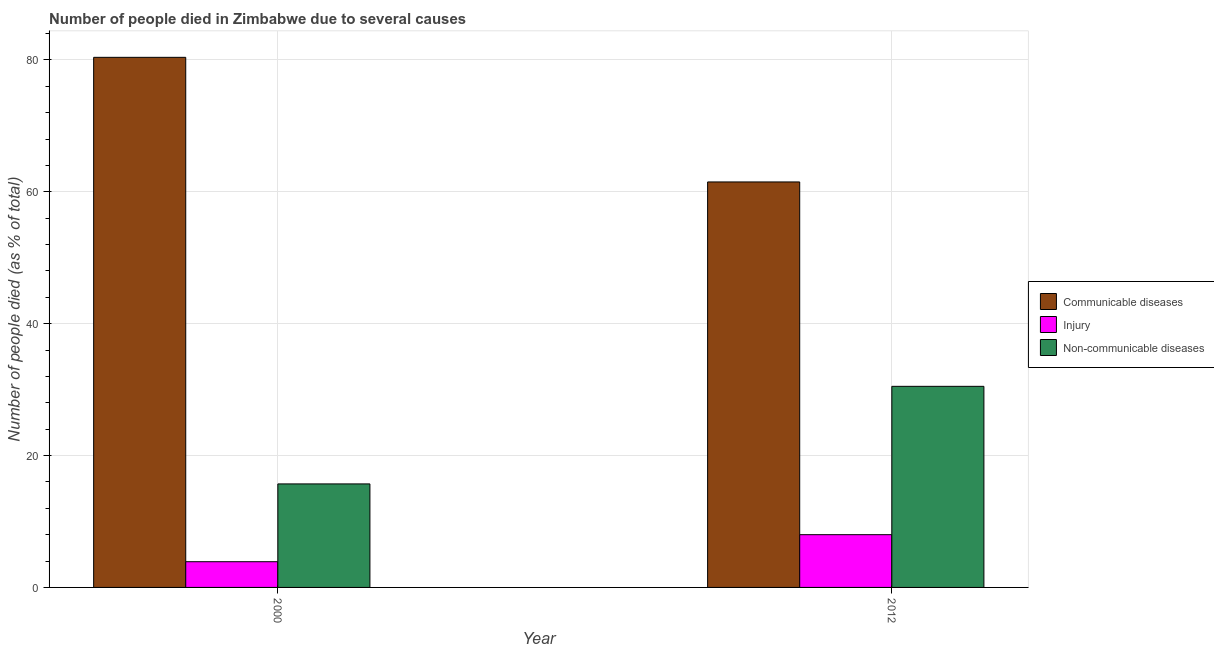Are the number of bars per tick equal to the number of legend labels?
Provide a succinct answer. Yes. Are the number of bars on each tick of the X-axis equal?
Provide a succinct answer. Yes. How many bars are there on the 2nd tick from the left?
Offer a terse response. 3. What is the label of the 1st group of bars from the left?
Provide a short and direct response. 2000. What is the number of people who dies of non-communicable diseases in 2012?
Your answer should be very brief. 30.5. Across all years, what is the maximum number of people who died of communicable diseases?
Give a very brief answer. 80.4. What is the total number of people who died of communicable diseases in the graph?
Your answer should be compact. 141.9. What is the difference between the number of people who died of communicable diseases in 2000 and that in 2012?
Keep it short and to the point. 18.9. What is the difference between the number of people who died of communicable diseases in 2000 and the number of people who died of injury in 2012?
Offer a terse response. 18.9. What is the average number of people who dies of non-communicable diseases per year?
Provide a short and direct response. 23.1. In the year 2012, what is the difference between the number of people who dies of non-communicable diseases and number of people who died of communicable diseases?
Ensure brevity in your answer.  0. In how many years, is the number of people who died of communicable diseases greater than 72 %?
Offer a very short reply. 1. What is the ratio of the number of people who died of communicable diseases in 2000 to that in 2012?
Your response must be concise. 1.31. Is the number of people who dies of non-communicable diseases in 2000 less than that in 2012?
Give a very brief answer. Yes. In how many years, is the number of people who died of communicable diseases greater than the average number of people who died of communicable diseases taken over all years?
Keep it short and to the point. 1. What does the 1st bar from the left in 2000 represents?
Your response must be concise. Communicable diseases. What does the 2nd bar from the right in 2000 represents?
Make the answer very short. Injury. Is it the case that in every year, the sum of the number of people who died of communicable diseases and number of people who died of injury is greater than the number of people who dies of non-communicable diseases?
Give a very brief answer. Yes. Are all the bars in the graph horizontal?
Give a very brief answer. No. How many years are there in the graph?
Your answer should be compact. 2. What is the difference between two consecutive major ticks on the Y-axis?
Make the answer very short. 20. Does the graph contain any zero values?
Give a very brief answer. No. Does the graph contain grids?
Offer a very short reply. Yes. What is the title of the graph?
Offer a terse response. Number of people died in Zimbabwe due to several causes. What is the label or title of the Y-axis?
Your response must be concise. Number of people died (as % of total). What is the Number of people died (as % of total) of Communicable diseases in 2000?
Give a very brief answer. 80.4. What is the Number of people died (as % of total) of Communicable diseases in 2012?
Give a very brief answer. 61.5. What is the Number of people died (as % of total) in Injury in 2012?
Ensure brevity in your answer.  8. What is the Number of people died (as % of total) in Non-communicable diseases in 2012?
Your response must be concise. 30.5. Across all years, what is the maximum Number of people died (as % of total) in Communicable diseases?
Offer a terse response. 80.4. Across all years, what is the maximum Number of people died (as % of total) of Non-communicable diseases?
Keep it short and to the point. 30.5. Across all years, what is the minimum Number of people died (as % of total) in Communicable diseases?
Provide a short and direct response. 61.5. Across all years, what is the minimum Number of people died (as % of total) in Non-communicable diseases?
Make the answer very short. 15.7. What is the total Number of people died (as % of total) of Communicable diseases in the graph?
Ensure brevity in your answer.  141.9. What is the total Number of people died (as % of total) of Non-communicable diseases in the graph?
Your answer should be very brief. 46.2. What is the difference between the Number of people died (as % of total) in Communicable diseases in 2000 and that in 2012?
Offer a very short reply. 18.9. What is the difference between the Number of people died (as % of total) in Injury in 2000 and that in 2012?
Give a very brief answer. -4.1. What is the difference between the Number of people died (as % of total) of Non-communicable diseases in 2000 and that in 2012?
Your answer should be very brief. -14.8. What is the difference between the Number of people died (as % of total) in Communicable diseases in 2000 and the Number of people died (as % of total) in Injury in 2012?
Your answer should be very brief. 72.4. What is the difference between the Number of people died (as % of total) of Communicable diseases in 2000 and the Number of people died (as % of total) of Non-communicable diseases in 2012?
Give a very brief answer. 49.9. What is the difference between the Number of people died (as % of total) in Injury in 2000 and the Number of people died (as % of total) in Non-communicable diseases in 2012?
Give a very brief answer. -26.6. What is the average Number of people died (as % of total) in Communicable diseases per year?
Your answer should be very brief. 70.95. What is the average Number of people died (as % of total) in Injury per year?
Your answer should be compact. 5.95. What is the average Number of people died (as % of total) of Non-communicable diseases per year?
Give a very brief answer. 23.1. In the year 2000, what is the difference between the Number of people died (as % of total) in Communicable diseases and Number of people died (as % of total) in Injury?
Keep it short and to the point. 76.5. In the year 2000, what is the difference between the Number of people died (as % of total) in Communicable diseases and Number of people died (as % of total) in Non-communicable diseases?
Your answer should be very brief. 64.7. In the year 2000, what is the difference between the Number of people died (as % of total) of Injury and Number of people died (as % of total) of Non-communicable diseases?
Provide a succinct answer. -11.8. In the year 2012, what is the difference between the Number of people died (as % of total) of Communicable diseases and Number of people died (as % of total) of Injury?
Your response must be concise. 53.5. In the year 2012, what is the difference between the Number of people died (as % of total) in Injury and Number of people died (as % of total) in Non-communicable diseases?
Offer a terse response. -22.5. What is the ratio of the Number of people died (as % of total) in Communicable diseases in 2000 to that in 2012?
Give a very brief answer. 1.31. What is the ratio of the Number of people died (as % of total) in Injury in 2000 to that in 2012?
Your response must be concise. 0.49. What is the ratio of the Number of people died (as % of total) of Non-communicable diseases in 2000 to that in 2012?
Give a very brief answer. 0.51. What is the difference between the highest and the second highest Number of people died (as % of total) in Communicable diseases?
Your answer should be very brief. 18.9. What is the difference between the highest and the second highest Number of people died (as % of total) of Non-communicable diseases?
Give a very brief answer. 14.8. What is the difference between the highest and the lowest Number of people died (as % of total) in Non-communicable diseases?
Give a very brief answer. 14.8. 